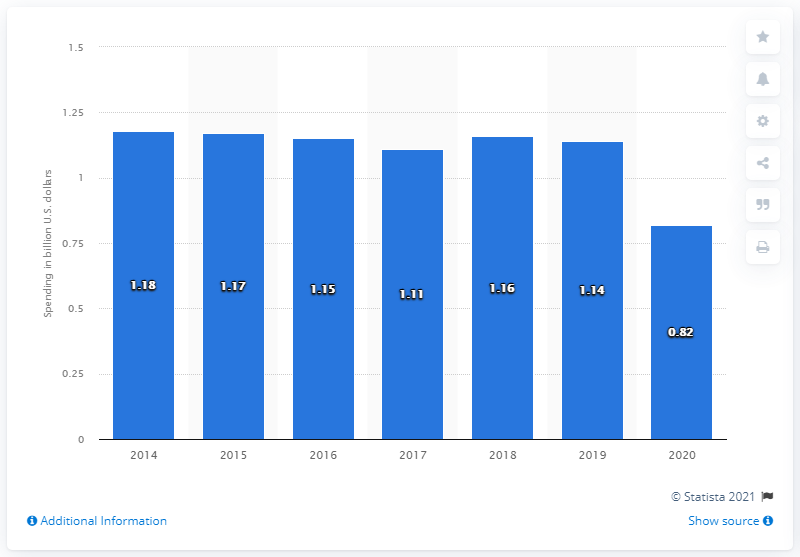Give some essential details in this illustration. The company invested 0.82 million dollars in advertising in fiscal year 2020. 